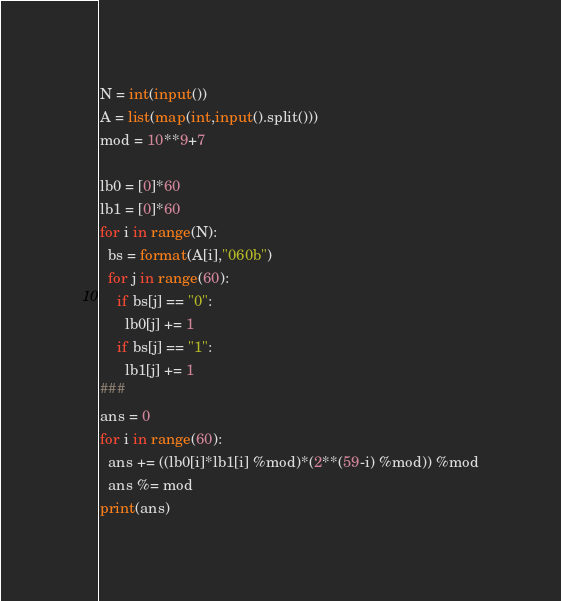Convert code to text. <code><loc_0><loc_0><loc_500><loc_500><_Python_>N = int(input())
A = list(map(int,input().split()))
mod = 10**9+7 

lb0 = [0]*60
lb1 = [0]*60
for i in range(N):
  bs = format(A[i],"060b")
  for j in range(60):
    if bs[j] == "0":
      lb0[j] += 1
    if bs[j] == "1":
      lb1[j] += 1  
###
ans = 0
for i in range(60):
  ans += ((lb0[i]*lb1[i] %mod)*(2**(59-i) %mod)) %mod
  ans %= mod
print(ans)  </code> 